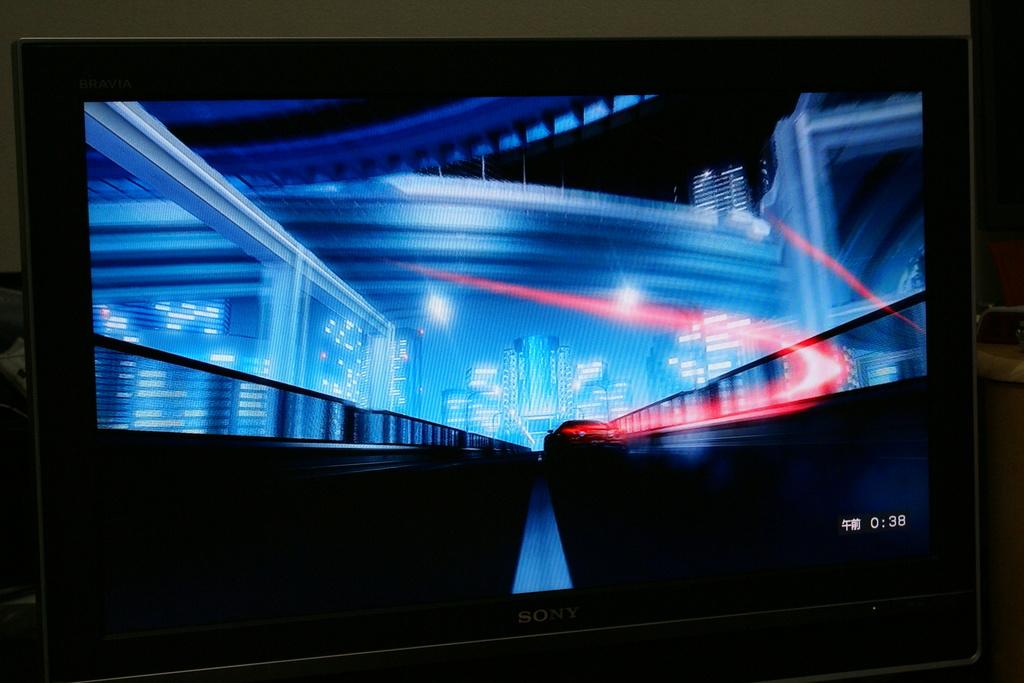The counter is on the bottom right?
Your response must be concise. Yes. 